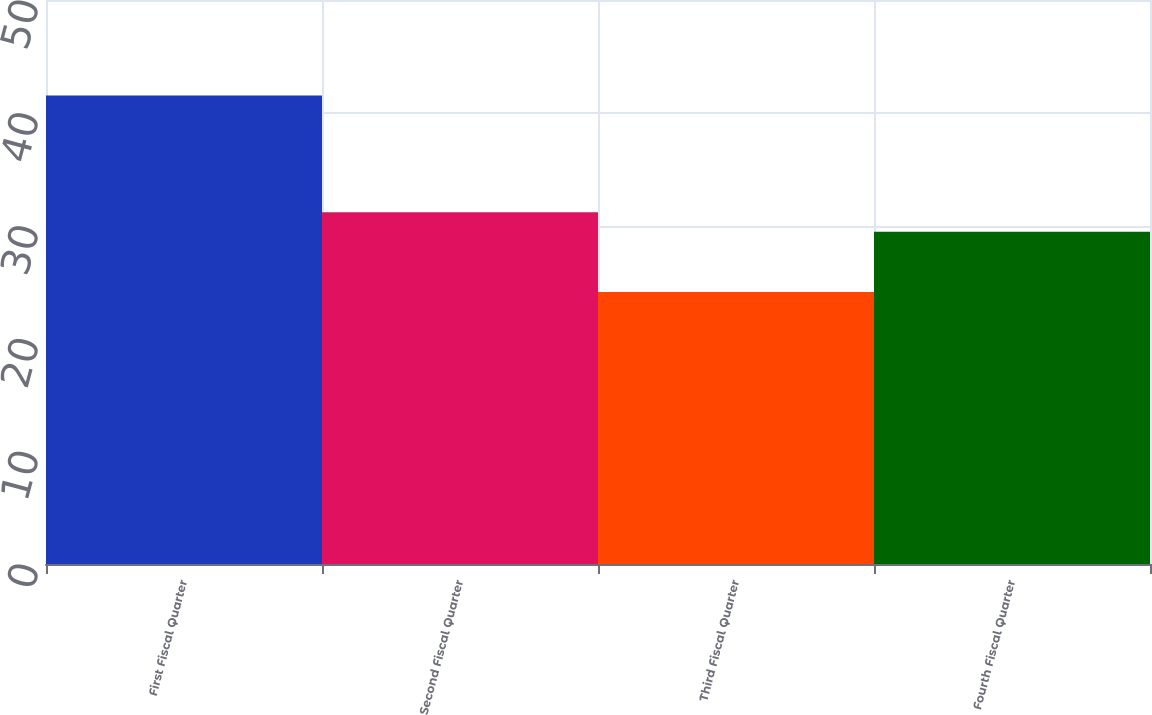<chart> <loc_0><loc_0><loc_500><loc_500><bar_chart><fcel>First Fiscal Quarter<fcel>Second Fiscal Quarter<fcel>Third Fiscal Quarter<fcel>Fourth Fiscal Quarter<nl><fcel>41.54<fcel>31.19<fcel>24.11<fcel>29.45<nl></chart> 